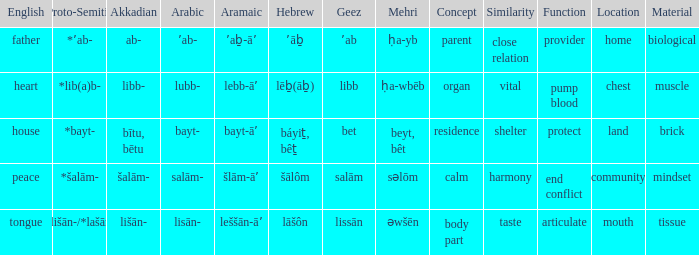If in english it is heart, what is it in hebrew? Lēḇ(āḇ). 